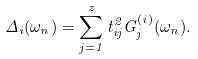Convert formula to latex. <formula><loc_0><loc_0><loc_500><loc_500>\Delta _ { i } ( \omega _ { n } ) = \sum _ { j = 1 } ^ { z } t _ { i j } ^ { 2 } G _ { j } ^ { ( i ) } ( \omega _ { n } ) .</formula> 